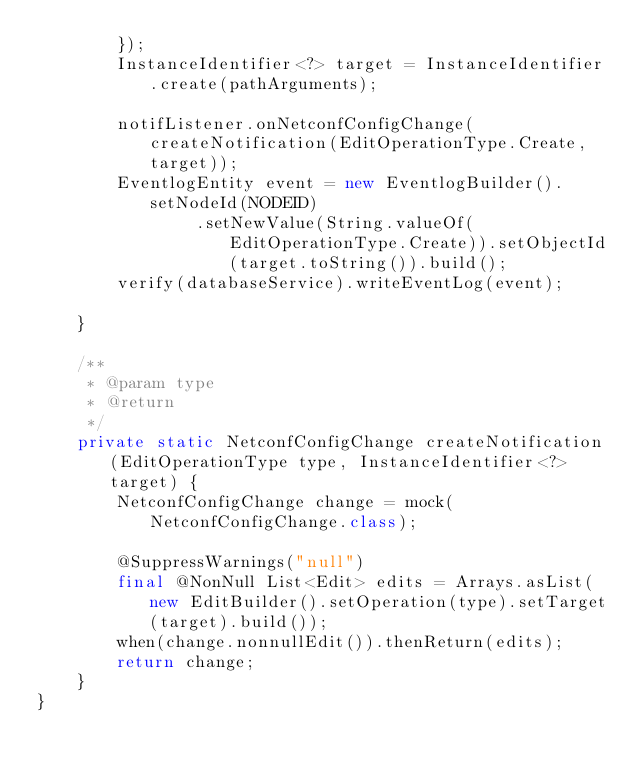<code> <loc_0><loc_0><loc_500><loc_500><_Java_>        });
        InstanceIdentifier<?> target = InstanceIdentifier.create(pathArguments);

        notifListener.onNetconfConfigChange(createNotification(EditOperationType.Create, target));
        EventlogEntity event = new EventlogBuilder().setNodeId(NODEID)
                .setNewValue(String.valueOf(EditOperationType.Create)).setObjectId(target.toString()).build();
        verify(databaseService).writeEventLog(event);

    }

    /**
     * @param type
     * @return
     */
    private static NetconfConfigChange createNotification(EditOperationType type, InstanceIdentifier<?> target) {
        NetconfConfigChange change = mock(NetconfConfigChange.class);

        @SuppressWarnings("null")
        final @NonNull List<Edit> edits = Arrays.asList(new EditBuilder().setOperation(type).setTarget(target).build());
        when(change.nonnullEdit()).thenReturn(edits);
        return change;
    }
}
</code> 